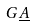Convert formula to latex. <formula><loc_0><loc_0><loc_500><loc_500>G \underline { A }</formula> 